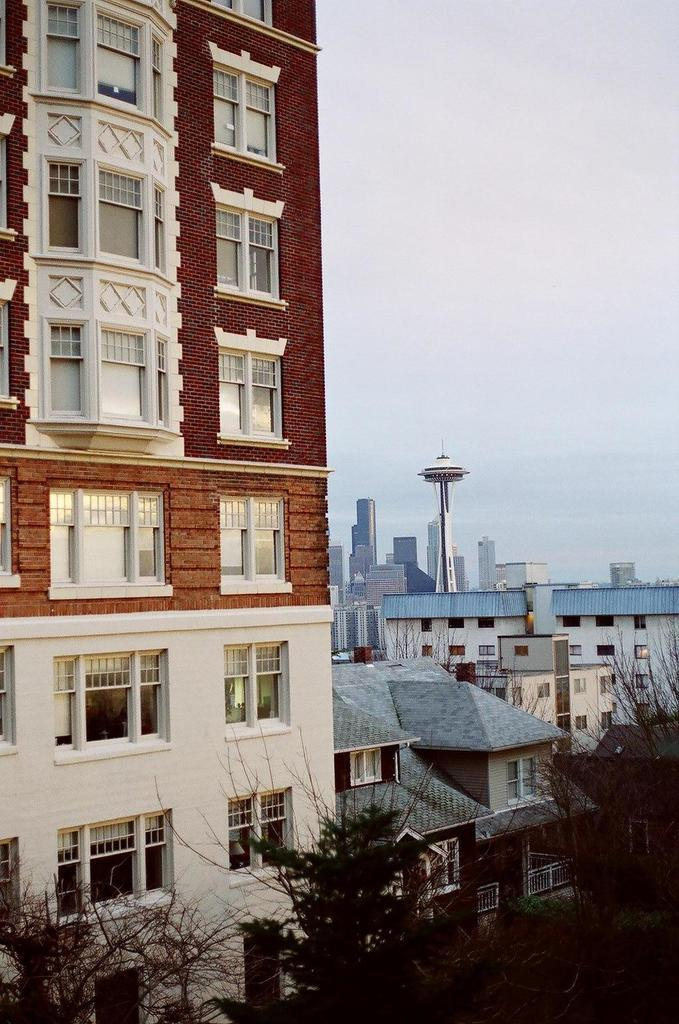What types of structures are present in the image? There are buildings in the image. What other natural elements can be seen in the image? There are trees in the image. What is visible in the background of the image? The sky is visible in the image. What type of milk can be seen being poured from a carton in the image? There is no milk or carton present in the image. How many tomatoes are visible on the trees in the image? There are no tomatoes present in the image, as it features buildings and trees without any fruits or vegetables. 